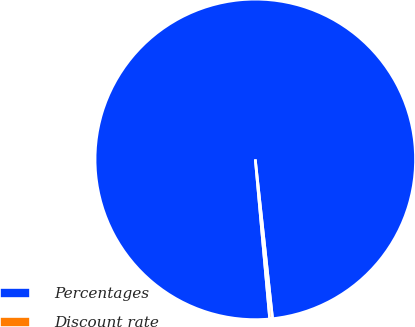Convert chart. <chart><loc_0><loc_0><loc_500><loc_500><pie_chart><fcel>Percentages<fcel>Discount rate<nl><fcel>99.71%<fcel>0.29%<nl></chart> 